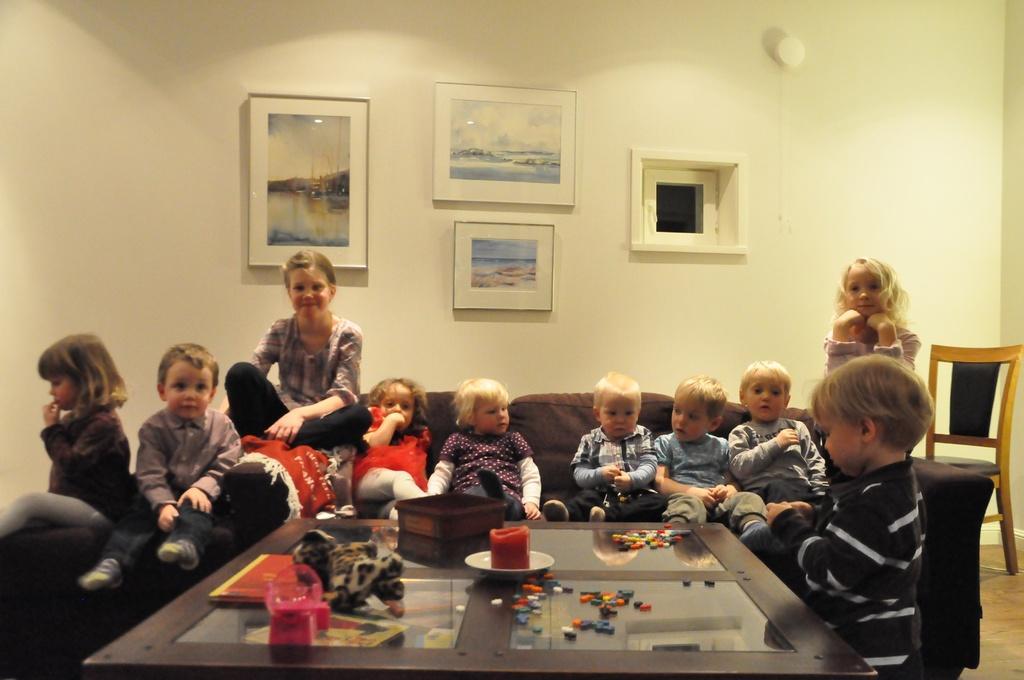Could you give a brief overview of what you see in this image? There are many kids sitting on the sofa. There is a table on the front. So many playing items are kept on the table. There is a plate and on the plate some item is kept. There is a box on the table. A toy is kept on the table. One book is there on the table. In the back there's a wall. And on the wall three photo frames are kept. And there is a switch on the wall. Also in the corner there is a chair. 